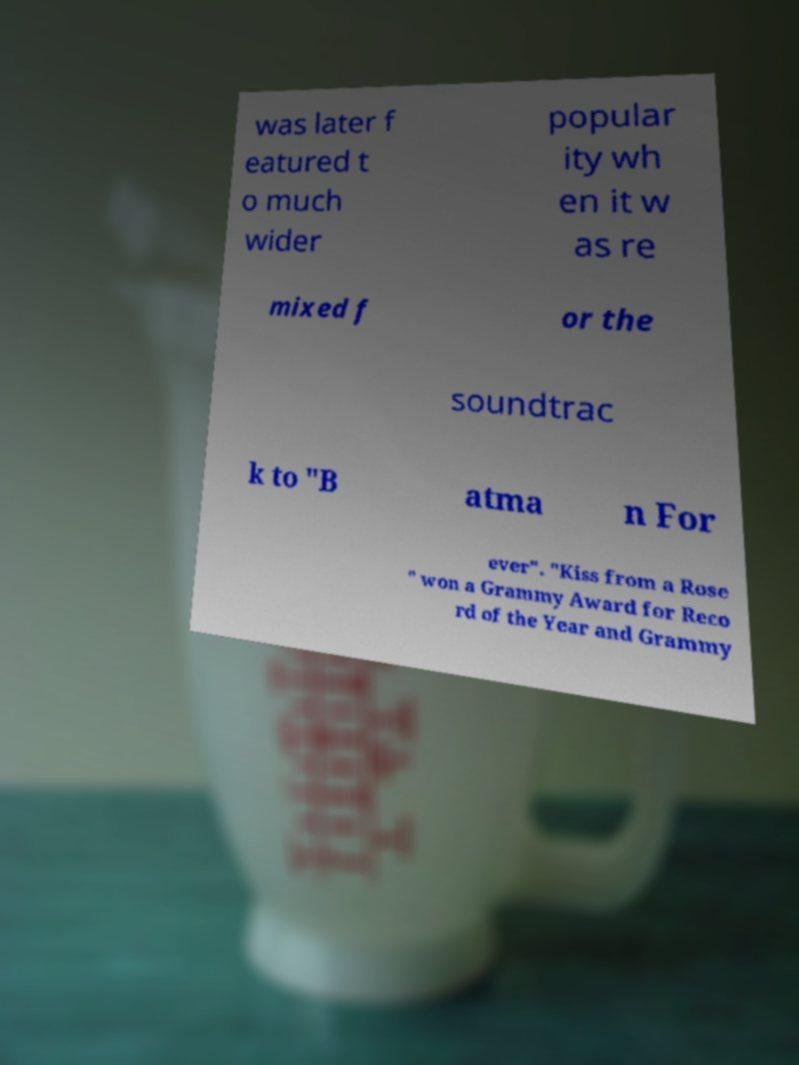I need the written content from this picture converted into text. Can you do that? was later f eatured t o much wider popular ity wh en it w as re mixed f or the soundtrac k to "B atma n For ever". "Kiss from a Rose " won a Grammy Award for Reco rd of the Year and Grammy 